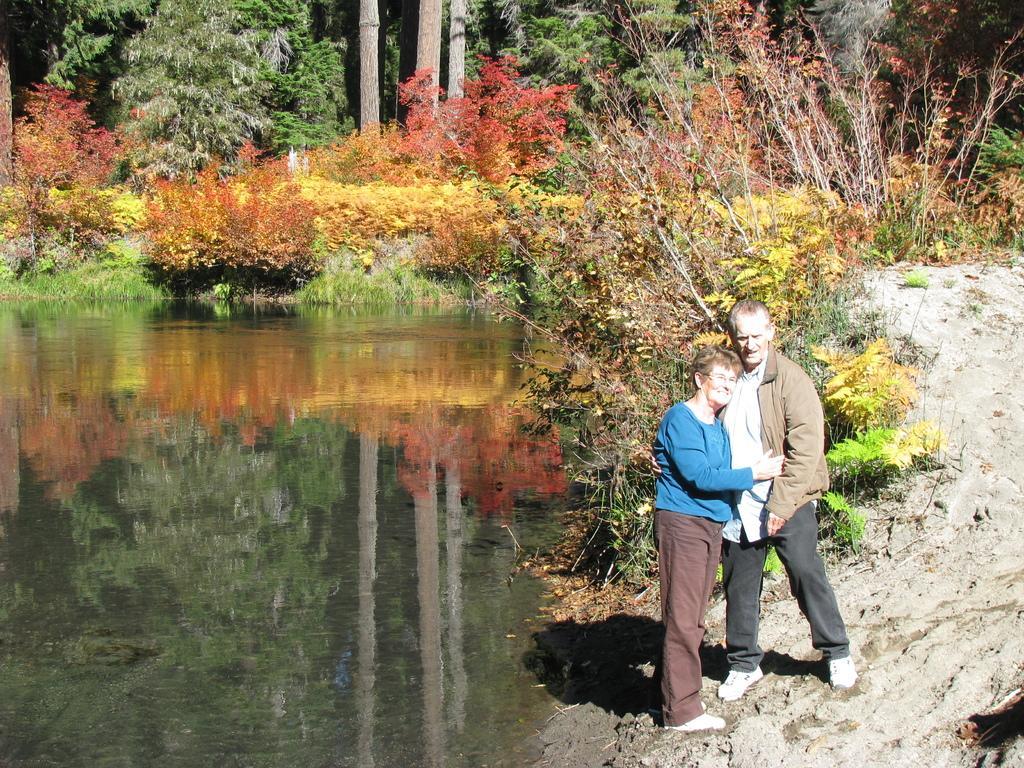Could you give a brief overview of what you see in this image? In this image we can see a man and woman. On the left side there is water. In the back there are trees. On the right side there is sand. 